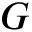Convert formula to latex. <formula><loc_0><loc_0><loc_500><loc_500>G</formula> 